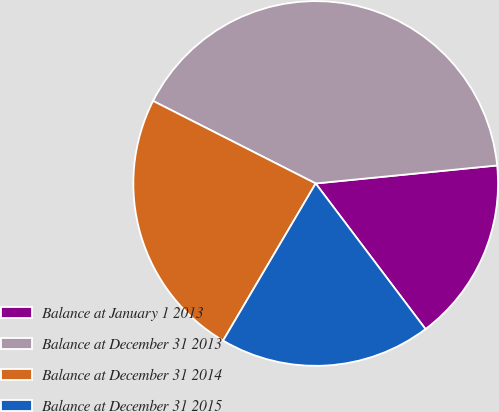<chart> <loc_0><loc_0><loc_500><loc_500><pie_chart><fcel>Balance at January 1 2013<fcel>Balance at December 31 2013<fcel>Balance at December 31 2014<fcel>Balance at December 31 2015<nl><fcel>16.29%<fcel>40.95%<fcel>24.0%<fcel>18.76%<nl></chart> 